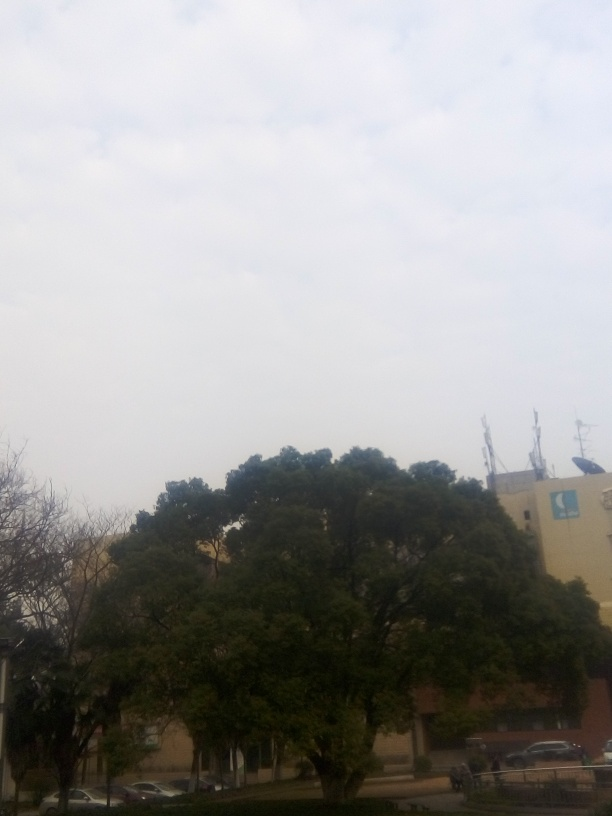Can you tell the time of day this photo was taken? Without strong shadows or a visible position of the sun, it's challenging to determine the exact time of day. However, the overall lightness of the sky suggests it might be daytime. What can you say about the building in the background? The building has a plain façade with minimal architectural detail, typical of functional commercial or institutional structures. It contrasts with the natural elements in the foreground, adding a layer of urban complexity to the scene. 